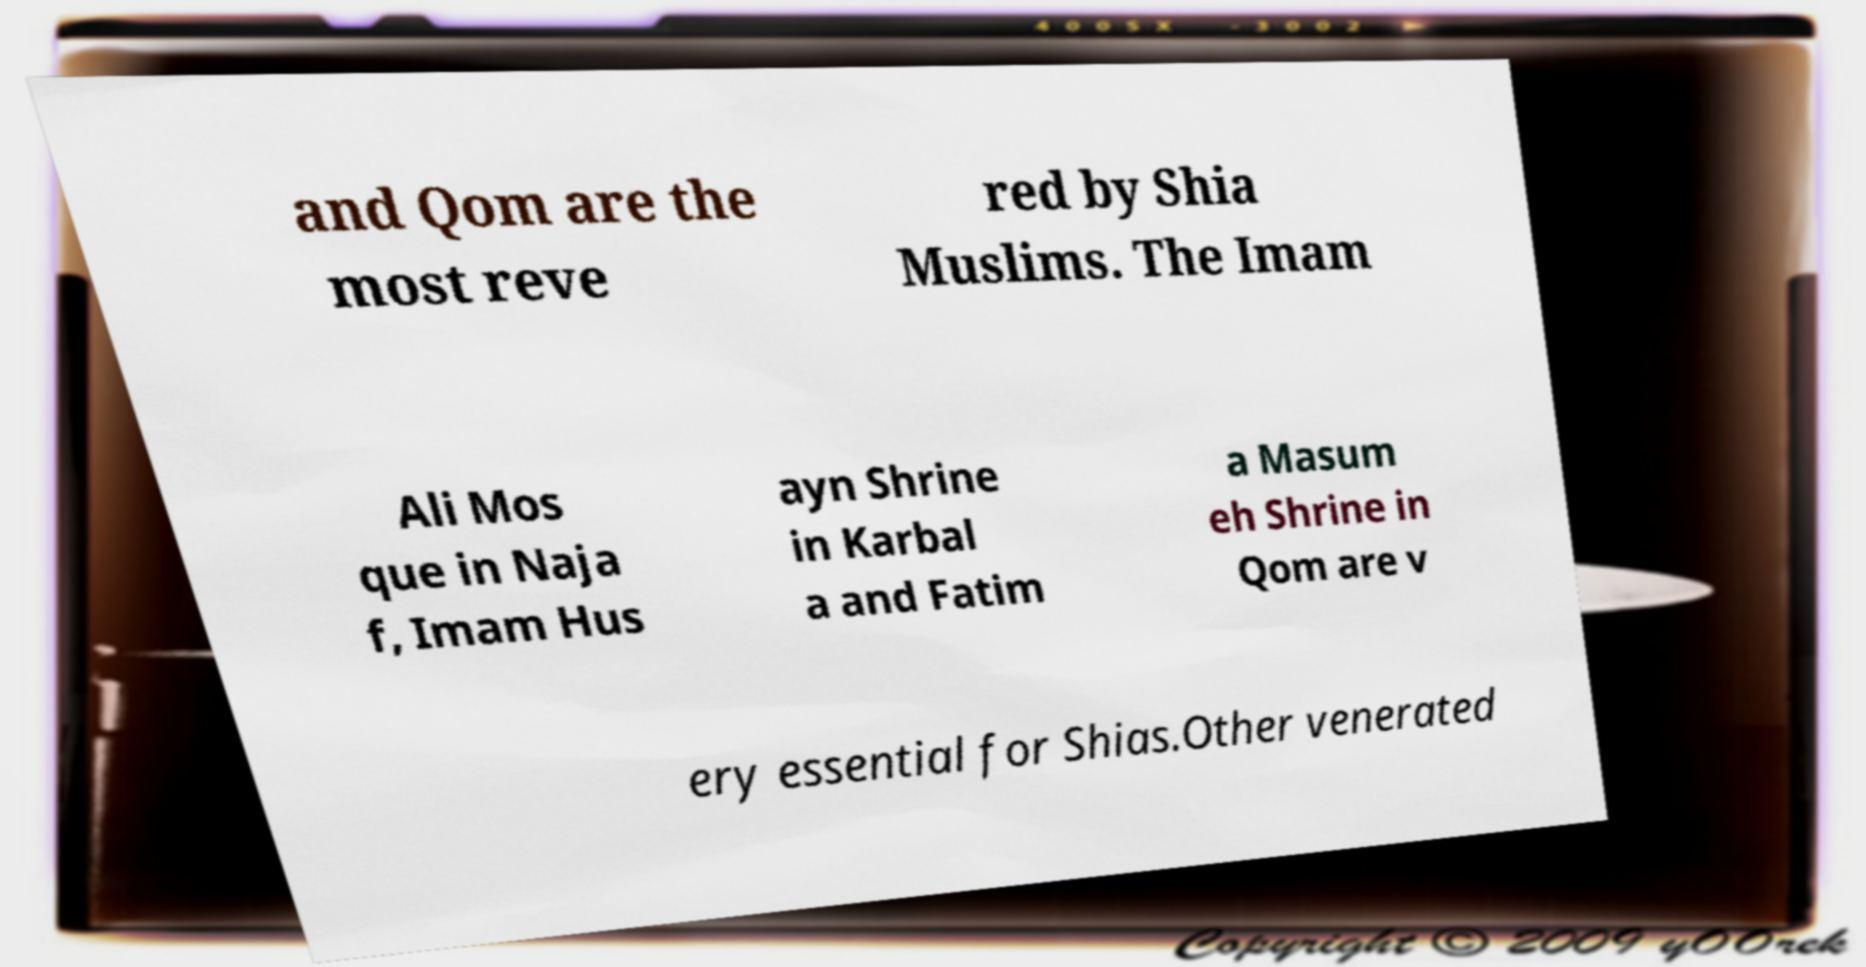Could you assist in decoding the text presented in this image and type it out clearly? and Qom are the most reve red by Shia Muslims. The Imam Ali Mos que in Naja f, Imam Hus ayn Shrine in Karbal a and Fatim a Masum eh Shrine in Qom are v ery essential for Shias.Other venerated 